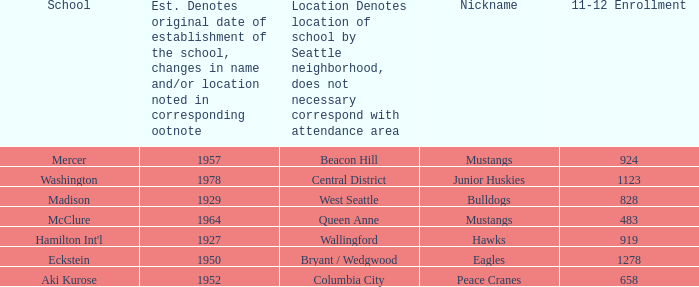Name the most 11-12 enrollment for columbia city 658.0. 